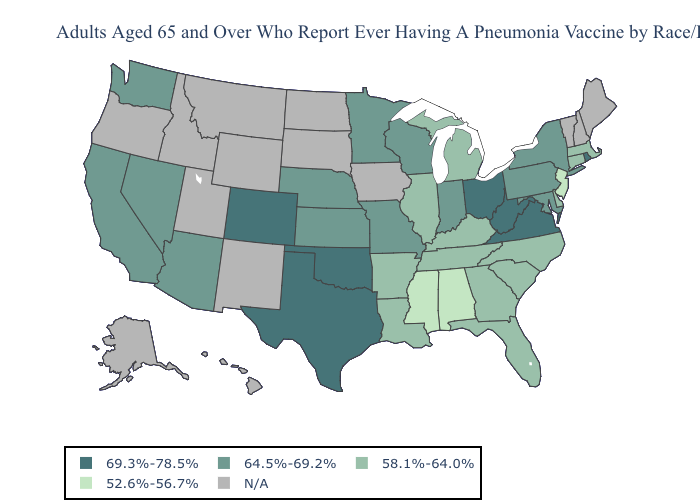Which states have the lowest value in the Northeast?
Write a very short answer. New Jersey. What is the value of Nevada?
Keep it brief. 64.5%-69.2%. What is the highest value in states that border Texas?
Answer briefly. 69.3%-78.5%. What is the value of Wyoming?
Write a very short answer. N/A. Name the states that have a value in the range 58.1%-64.0%?
Concise answer only. Arkansas, Connecticut, Delaware, Florida, Georgia, Illinois, Kentucky, Louisiana, Massachusetts, Michigan, North Carolina, South Carolina, Tennessee. Name the states that have a value in the range 69.3%-78.5%?
Write a very short answer. Colorado, Ohio, Oklahoma, Rhode Island, Texas, Virginia, West Virginia. Which states hav the highest value in the South?
Keep it brief. Oklahoma, Texas, Virginia, West Virginia. What is the lowest value in the USA?
Keep it brief. 52.6%-56.7%. Among the states that border Michigan , does Wisconsin have the lowest value?
Short answer required. Yes. Name the states that have a value in the range N/A?
Give a very brief answer. Alaska, Hawaii, Idaho, Iowa, Maine, Montana, New Hampshire, New Mexico, North Dakota, Oregon, South Dakota, Utah, Vermont, Wyoming. What is the lowest value in the USA?
Concise answer only. 52.6%-56.7%. Name the states that have a value in the range 58.1%-64.0%?
Give a very brief answer. Arkansas, Connecticut, Delaware, Florida, Georgia, Illinois, Kentucky, Louisiana, Massachusetts, Michigan, North Carolina, South Carolina, Tennessee. Among the states that border Mississippi , which have the highest value?
Quick response, please. Arkansas, Louisiana, Tennessee. Among the states that border Florida , which have the lowest value?
Answer briefly. Alabama. 